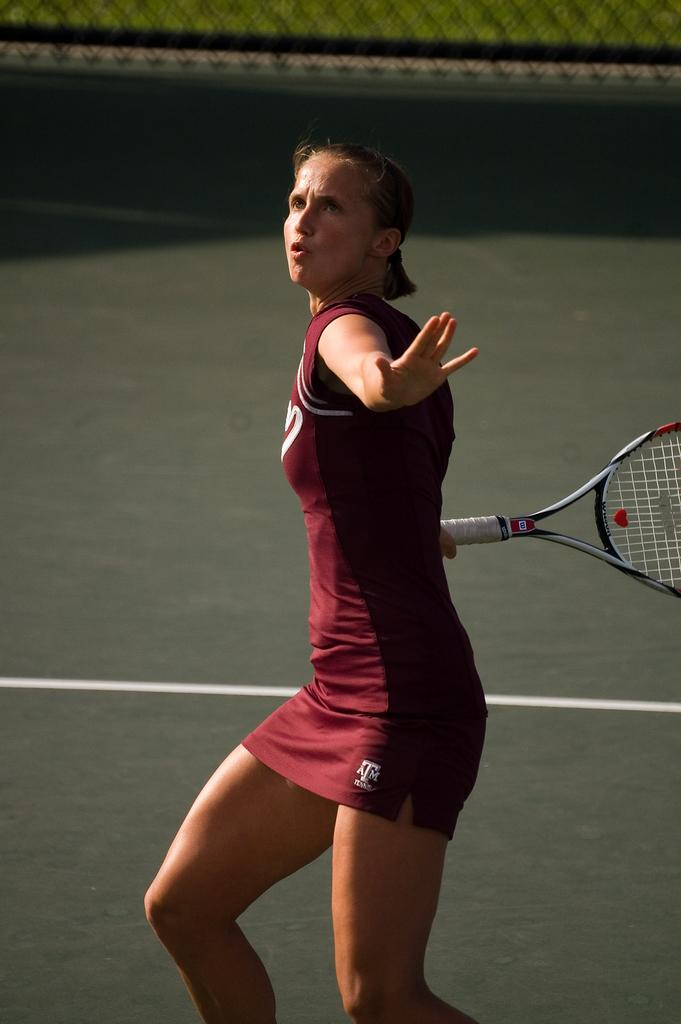Who is present in the image? There is a woman in the image. What is the woman holding in the image? The woman is holding a racket. What color is the woman's jersey? The woman is wearing a red jersey. What action is the woman about to perform? The woman is about to hit a ball. What can be seen in the background of the image? There is mesh and grass in the background of the image. What type of train can be seen in the background of the image? There is no train present in the background of the image; it features mesh and grass. Can you tell me how many chickens are visible in the image? There are no chickens present in the image; it features a woman holding a racket and wearing a red jersey. 